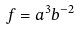<formula> <loc_0><loc_0><loc_500><loc_500>f = a ^ { 3 } b ^ { - 2 }</formula> 